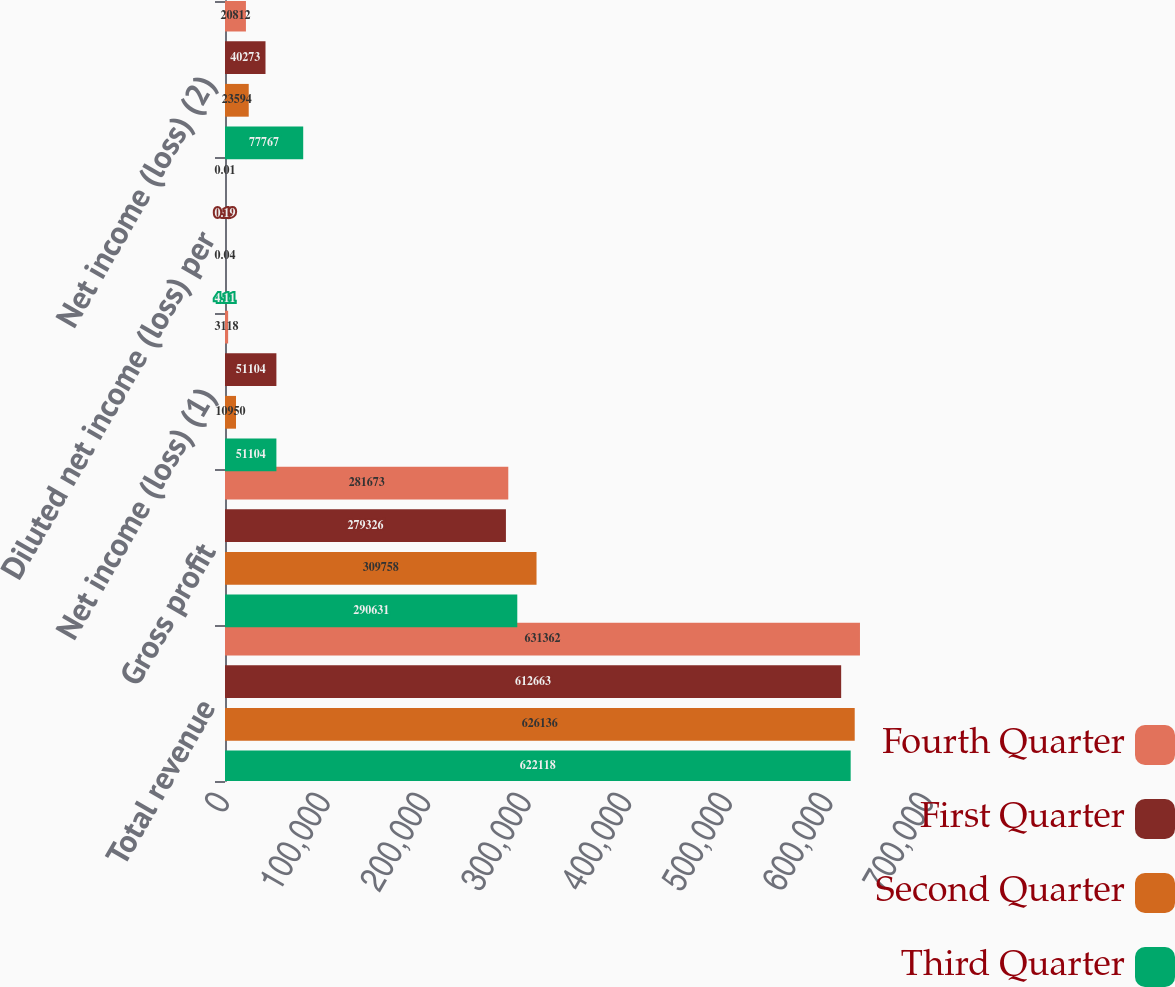<chart> <loc_0><loc_0><loc_500><loc_500><stacked_bar_chart><ecel><fcel>Total revenue<fcel>Gross profit<fcel>Net income (loss) (1)<fcel>Diluted net income (loss) per<fcel>Net income (loss) (2)<nl><fcel>Fourth Quarter<fcel>631362<fcel>281673<fcel>3118<fcel>0.01<fcel>20812<nl><fcel>First Quarter<fcel>612663<fcel>279326<fcel>51104<fcel>0.19<fcel>40273<nl><fcel>Second Quarter<fcel>626136<fcel>309758<fcel>10950<fcel>0.04<fcel>23594<nl><fcel>Third Quarter<fcel>622118<fcel>290631<fcel>51104<fcel>4.11<fcel>77767<nl></chart> 